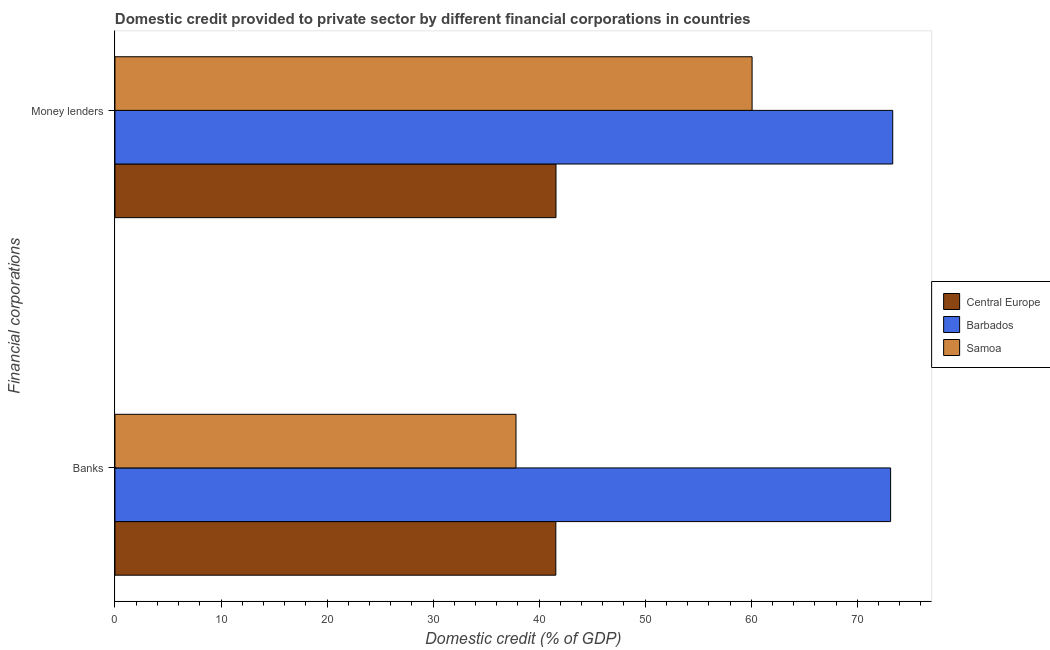Are the number of bars per tick equal to the number of legend labels?
Make the answer very short. Yes. How many bars are there on the 2nd tick from the top?
Keep it short and to the point. 3. How many bars are there on the 1st tick from the bottom?
Offer a very short reply. 3. What is the label of the 2nd group of bars from the top?
Make the answer very short. Banks. What is the domestic credit provided by money lenders in Samoa?
Keep it short and to the point. 60.08. Across all countries, what is the maximum domestic credit provided by money lenders?
Offer a very short reply. 73.35. Across all countries, what is the minimum domestic credit provided by banks?
Provide a succinct answer. 37.82. In which country was the domestic credit provided by banks maximum?
Give a very brief answer. Barbados. In which country was the domestic credit provided by money lenders minimum?
Give a very brief answer. Central Europe. What is the total domestic credit provided by money lenders in the graph?
Make the answer very short. 175.02. What is the difference between the domestic credit provided by banks in Samoa and that in Central Europe?
Your response must be concise. -3.76. What is the difference between the domestic credit provided by banks in Barbados and the domestic credit provided by money lenders in Central Europe?
Offer a terse response. 31.55. What is the average domestic credit provided by banks per country?
Offer a very short reply. 50.85. What is the difference between the domestic credit provided by money lenders and domestic credit provided by banks in Central Europe?
Your response must be concise. 0.01. In how many countries, is the domestic credit provided by money lenders greater than 72 %?
Offer a terse response. 1. What is the ratio of the domestic credit provided by banks in Samoa to that in Central Europe?
Ensure brevity in your answer.  0.91. In how many countries, is the domestic credit provided by money lenders greater than the average domestic credit provided by money lenders taken over all countries?
Give a very brief answer. 2. What does the 2nd bar from the top in Banks represents?
Your response must be concise. Barbados. What does the 1st bar from the bottom in Money lenders represents?
Your answer should be compact. Central Europe. How many bars are there?
Keep it short and to the point. 6. Are all the bars in the graph horizontal?
Keep it short and to the point. Yes. How many countries are there in the graph?
Offer a very short reply. 3. What is the difference between two consecutive major ticks on the X-axis?
Offer a terse response. 10. Are the values on the major ticks of X-axis written in scientific E-notation?
Your response must be concise. No. Where does the legend appear in the graph?
Your response must be concise. Center right. How many legend labels are there?
Offer a terse response. 3. What is the title of the graph?
Give a very brief answer. Domestic credit provided to private sector by different financial corporations in countries. What is the label or title of the X-axis?
Your answer should be compact. Domestic credit (% of GDP). What is the label or title of the Y-axis?
Give a very brief answer. Financial corporations. What is the Domestic credit (% of GDP) of Central Europe in Banks?
Your answer should be very brief. 41.58. What is the Domestic credit (% of GDP) of Barbados in Banks?
Your answer should be compact. 73.15. What is the Domestic credit (% of GDP) in Samoa in Banks?
Your response must be concise. 37.82. What is the Domestic credit (% of GDP) of Central Europe in Money lenders?
Make the answer very short. 41.59. What is the Domestic credit (% of GDP) in Barbados in Money lenders?
Offer a terse response. 73.35. What is the Domestic credit (% of GDP) in Samoa in Money lenders?
Your answer should be compact. 60.08. Across all Financial corporations, what is the maximum Domestic credit (% of GDP) in Central Europe?
Keep it short and to the point. 41.59. Across all Financial corporations, what is the maximum Domestic credit (% of GDP) of Barbados?
Keep it short and to the point. 73.35. Across all Financial corporations, what is the maximum Domestic credit (% of GDP) of Samoa?
Your response must be concise. 60.08. Across all Financial corporations, what is the minimum Domestic credit (% of GDP) in Central Europe?
Your answer should be very brief. 41.58. Across all Financial corporations, what is the minimum Domestic credit (% of GDP) of Barbados?
Your answer should be very brief. 73.15. Across all Financial corporations, what is the minimum Domestic credit (% of GDP) in Samoa?
Your response must be concise. 37.82. What is the total Domestic credit (% of GDP) of Central Europe in the graph?
Make the answer very short. 83.17. What is the total Domestic credit (% of GDP) in Barbados in the graph?
Your answer should be very brief. 146.49. What is the total Domestic credit (% of GDP) of Samoa in the graph?
Provide a succinct answer. 97.9. What is the difference between the Domestic credit (% of GDP) of Central Europe in Banks and that in Money lenders?
Keep it short and to the point. -0.01. What is the difference between the Domestic credit (% of GDP) in Barbados in Banks and that in Money lenders?
Your answer should be compact. -0.2. What is the difference between the Domestic credit (% of GDP) in Samoa in Banks and that in Money lenders?
Keep it short and to the point. -22.26. What is the difference between the Domestic credit (% of GDP) of Central Europe in Banks and the Domestic credit (% of GDP) of Barbados in Money lenders?
Make the answer very short. -31.77. What is the difference between the Domestic credit (% of GDP) in Central Europe in Banks and the Domestic credit (% of GDP) in Samoa in Money lenders?
Make the answer very short. -18.51. What is the difference between the Domestic credit (% of GDP) of Barbados in Banks and the Domestic credit (% of GDP) of Samoa in Money lenders?
Your response must be concise. 13.06. What is the average Domestic credit (% of GDP) of Central Europe per Financial corporations?
Ensure brevity in your answer.  41.58. What is the average Domestic credit (% of GDP) in Barbados per Financial corporations?
Provide a succinct answer. 73.25. What is the average Domestic credit (% of GDP) of Samoa per Financial corporations?
Provide a short and direct response. 48.95. What is the difference between the Domestic credit (% of GDP) in Central Europe and Domestic credit (% of GDP) in Barbados in Banks?
Provide a succinct answer. -31.57. What is the difference between the Domestic credit (% of GDP) of Central Europe and Domestic credit (% of GDP) of Samoa in Banks?
Provide a succinct answer. 3.76. What is the difference between the Domestic credit (% of GDP) in Barbados and Domestic credit (% of GDP) in Samoa in Banks?
Keep it short and to the point. 35.33. What is the difference between the Domestic credit (% of GDP) of Central Europe and Domestic credit (% of GDP) of Barbados in Money lenders?
Ensure brevity in your answer.  -31.76. What is the difference between the Domestic credit (% of GDP) of Central Europe and Domestic credit (% of GDP) of Samoa in Money lenders?
Ensure brevity in your answer.  -18.49. What is the difference between the Domestic credit (% of GDP) of Barbados and Domestic credit (% of GDP) of Samoa in Money lenders?
Your answer should be compact. 13.26. What is the ratio of the Domestic credit (% of GDP) in Central Europe in Banks to that in Money lenders?
Provide a succinct answer. 1. What is the ratio of the Domestic credit (% of GDP) of Samoa in Banks to that in Money lenders?
Offer a very short reply. 0.63. What is the difference between the highest and the second highest Domestic credit (% of GDP) in Central Europe?
Offer a terse response. 0.01. What is the difference between the highest and the second highest Domestic credit (% of GDP) in Barbados?
Give a very brief answer. 0.2. What is the difference between the highest and the second highest Domestic credit (% of GDP) of Samoa?
Your answer should be very brief. 22.26. What is the difference between the highest and the lowest Domestic credit (% of GDP) in Central Europe?
Give a very brief answer. 0.01. What is the difference between the highest and the lowest Domestic credit (% of GDP) in Barbados?
Your answer should be compact. 0.2. What is the difference between the highest and the lowest Domestic credit (% of GDP) of Samoa?
Provide a succinct answer. 22.26. 